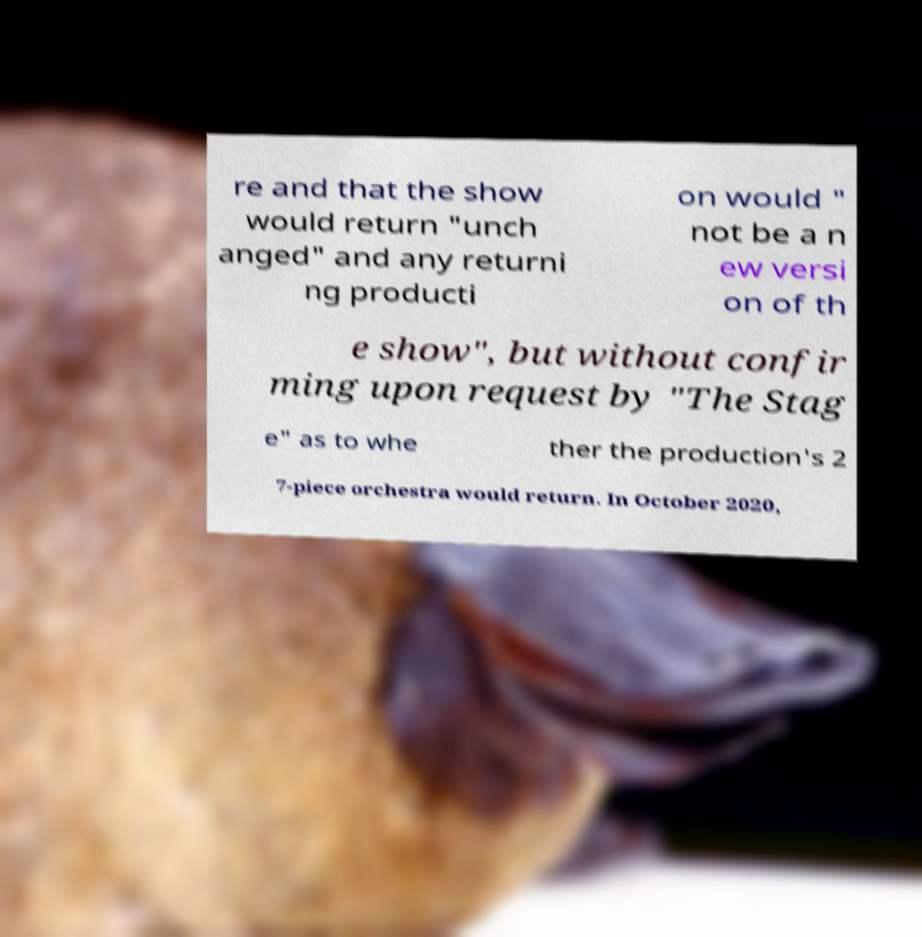I need the written content from this picture converted into text. Can you do that? re and that the show would return "unch anged" and any returni ng producti on would " not be a n ew versi on of th e show", but without confir ming upon request by "The Stag e" as to whe ther the production's 2 7-piece orchestra would return. In October 2020, 